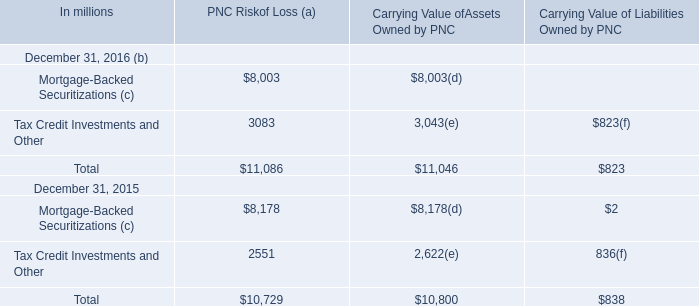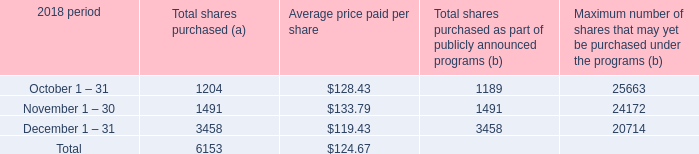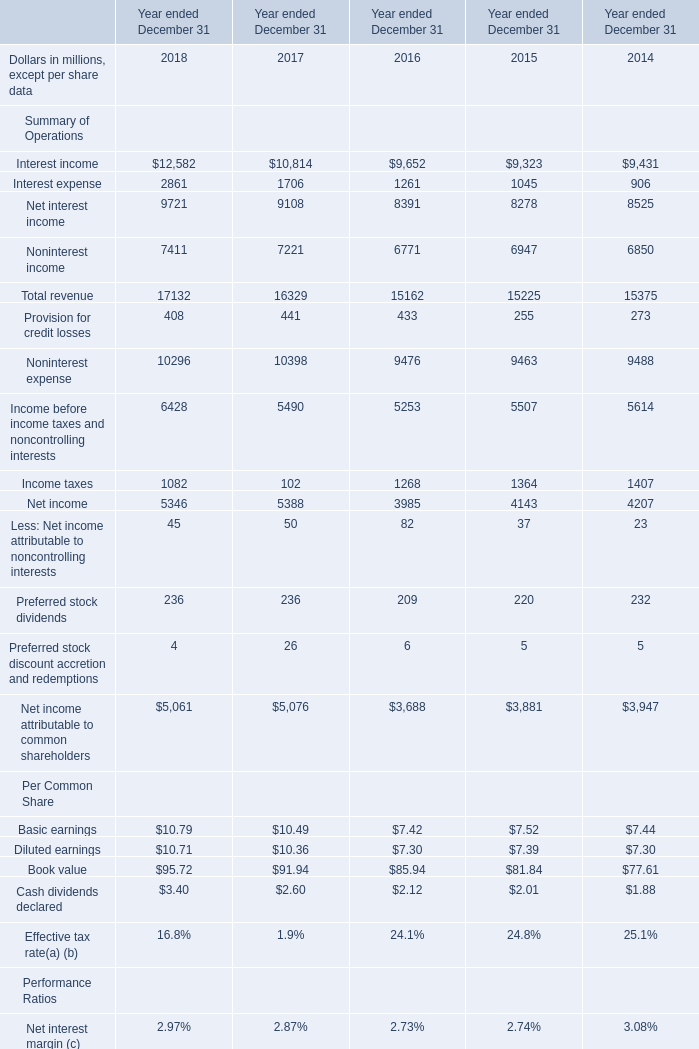What is the average increasing rate of Total revenue between 2016 ended December 31 and 2017 ended December 31? 
Computations: ((16329 - 15162) / 15162)
Answer: 0.07697. 